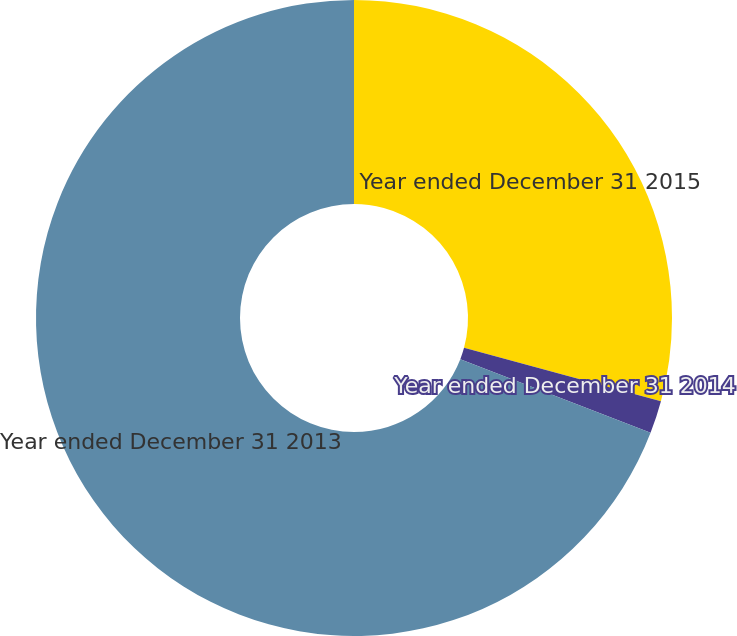Convert chart. <chart><loc_0><loc_0><loc_500><loc_500><pie_chart><fcel>Year ended December 31 2015<fcel>Year ended December 31 2014<fcel>Year ended December 31 2013<nl><fcel>29.21%<fcel>1.67%<fcel>69.12%<nl></chart> 